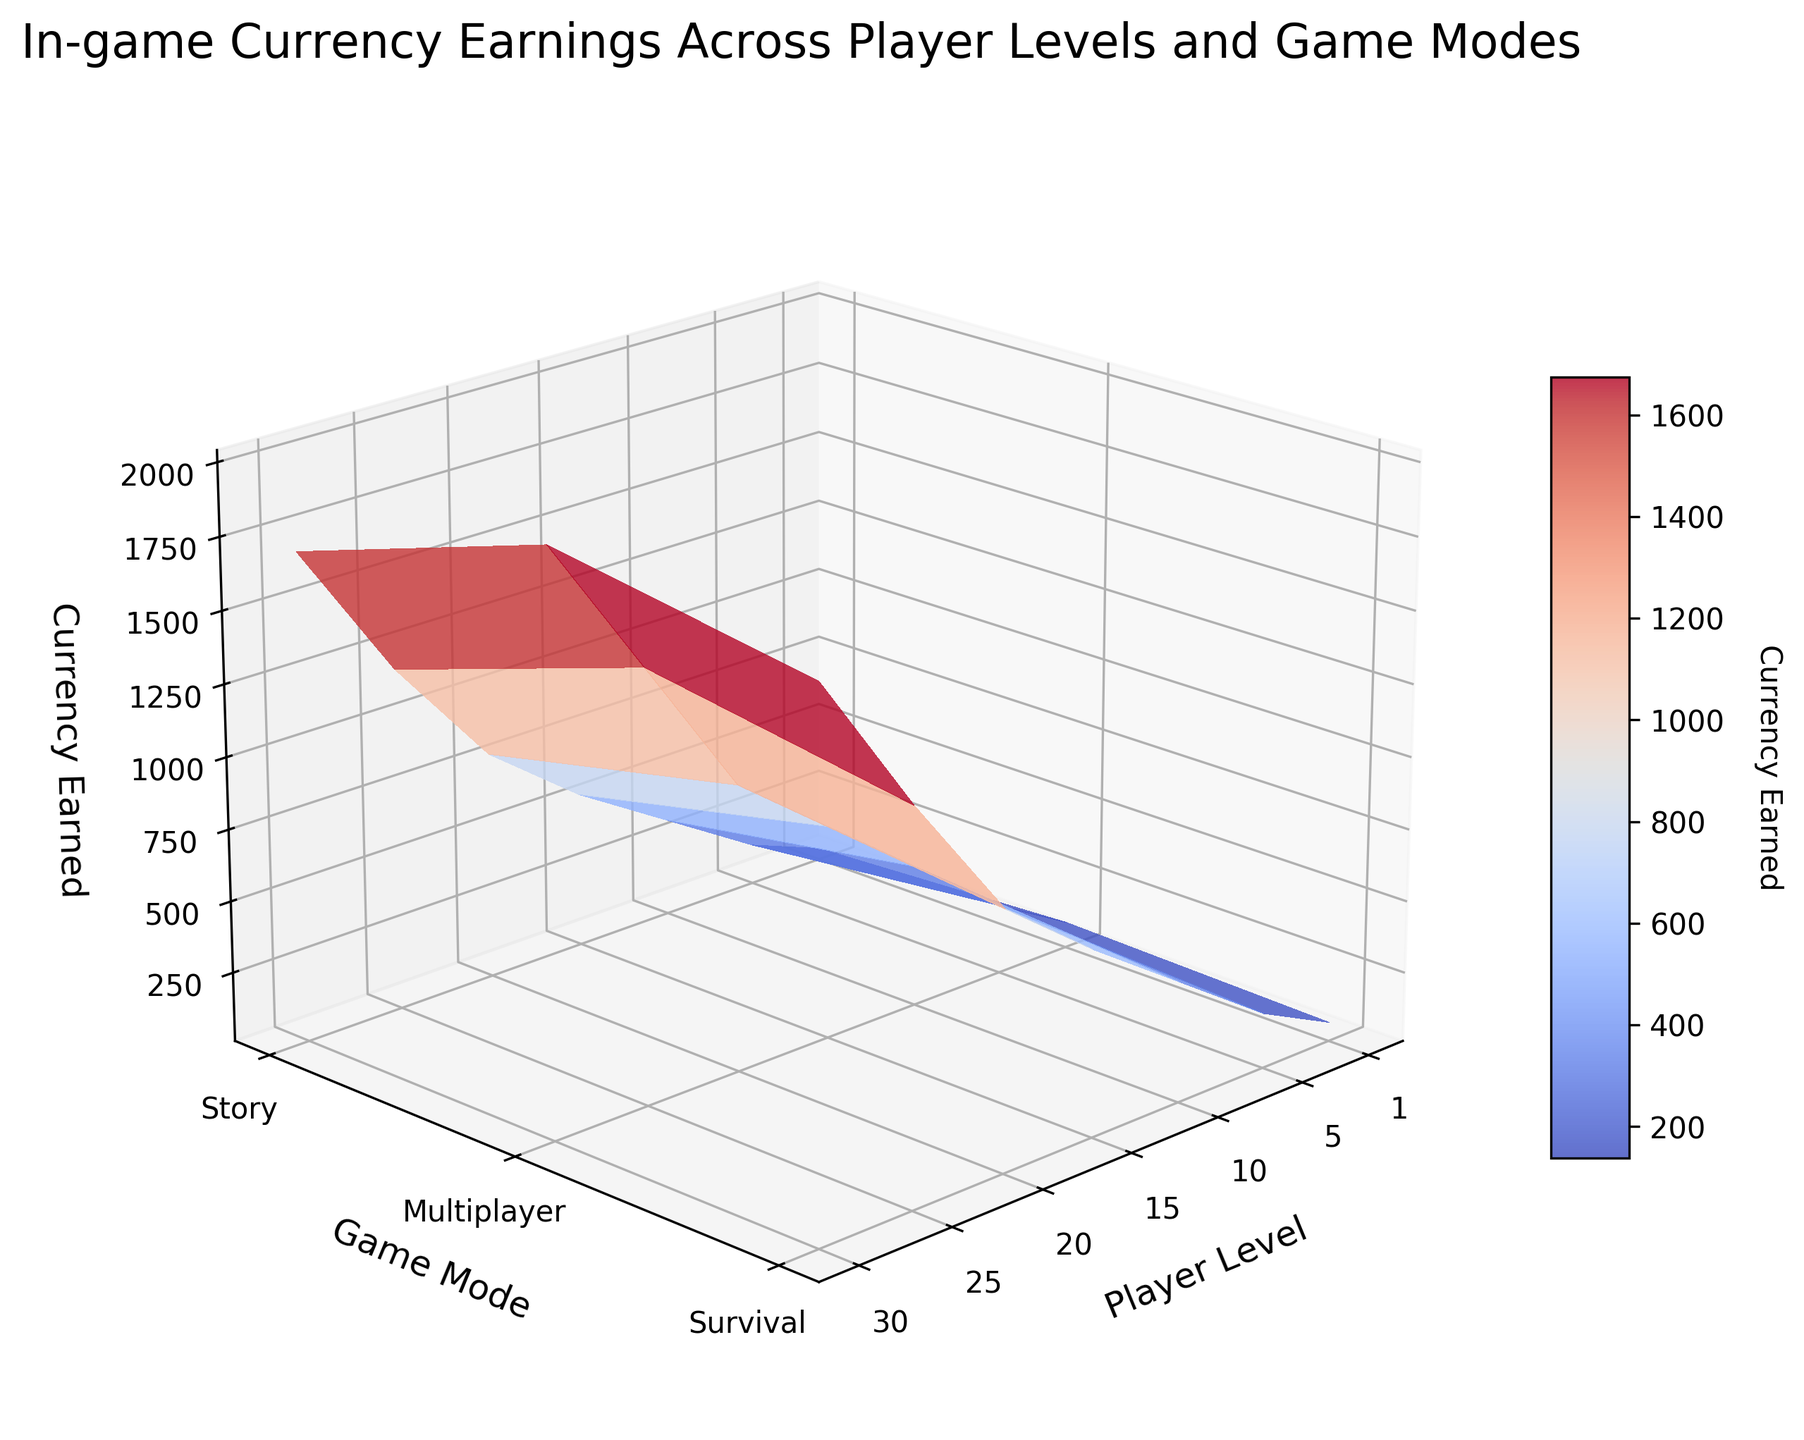What is the title of the 3D surface plot? The title of the plot is displayed at the top of the figure, which gives a summary of the information the plot represents.
Answer: In-game Currency Earnings Across Player Levels and Game Modes What are the labels for the three axes? The labels for the three axes are found next to each axis, indicating what each dimension represents.
Answer: Player Level, Game Mode, Currency Earned How does the currency earned change as player levels increase? To see how currency earned changes with player levels, observe the trend along the Player Level axis from lower to higher values. The surface's height (Z-axis) gradually increases as the player level increases, indicating a rise in currency earned.
Answer: Increases Which game mode generally offers the highest currency earned at each player level? Compare the height of the surface for each game mode at each player level along the Z-axis. The Story mode consistently appears at the highest points across all levels.
Answer: Story What is the difference in currency earned between Story and Multiplayer modes at level 10? Locate the currency values for Story and Multiplayer modes at level 10 on the Z-axis. The difference is the subtraction of the two values: 500 (Story) - 350 (Multiplayer).
Answer: 150 Which player level sees the highest increase in currency earned in Survival mode? Observe the surface heights corresponding to Survival mode, look for the level where the difference between consecutive levels is the largest. The increase from level 25 (1350) to level 30 (1850) is the highest (500) compared to other levels.
Answer: Level 30 What is the average currency earned across all game modes at level 5? Locate the currency values for all three modes at level 5: Story (250), Multiplayer (150), Survival (200). The average is calculated as (250 + 150 + 200) / 3.
Answer: 200 How does the grid affect the readability of the plot? The gridlines can help align the view with the axes, making it easier to determine the precise values for each point on the plot.
Answer: Enhances clarity When viewing from the provided angle, which game mode shows the steepest incline in currency earned across player levels? By observing the steepness of the plot's surface for each game mode when viewed at the specified angle (elev=20, azim=45), the Story mode shows the steepest increase.
Answer: Story 